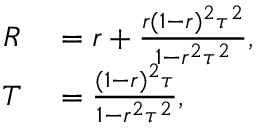Convert formula to latex. <formula><loc_0><loc_0><loc_500><loc_500>\begin{array} { r l } { R } & = r + \frac { r ( 1 - r ) ^ { 2 } \tau ^ { 2 } } { 1 - r ^ { 2 } \tau ^ { 2 } } , } \\ { T } & = \frac { ( 1 - r ) ^ { 2 } \tau } { 1 - r ^ { 2 } \tau ^ { 2 } } , } \end{array}</formula> 